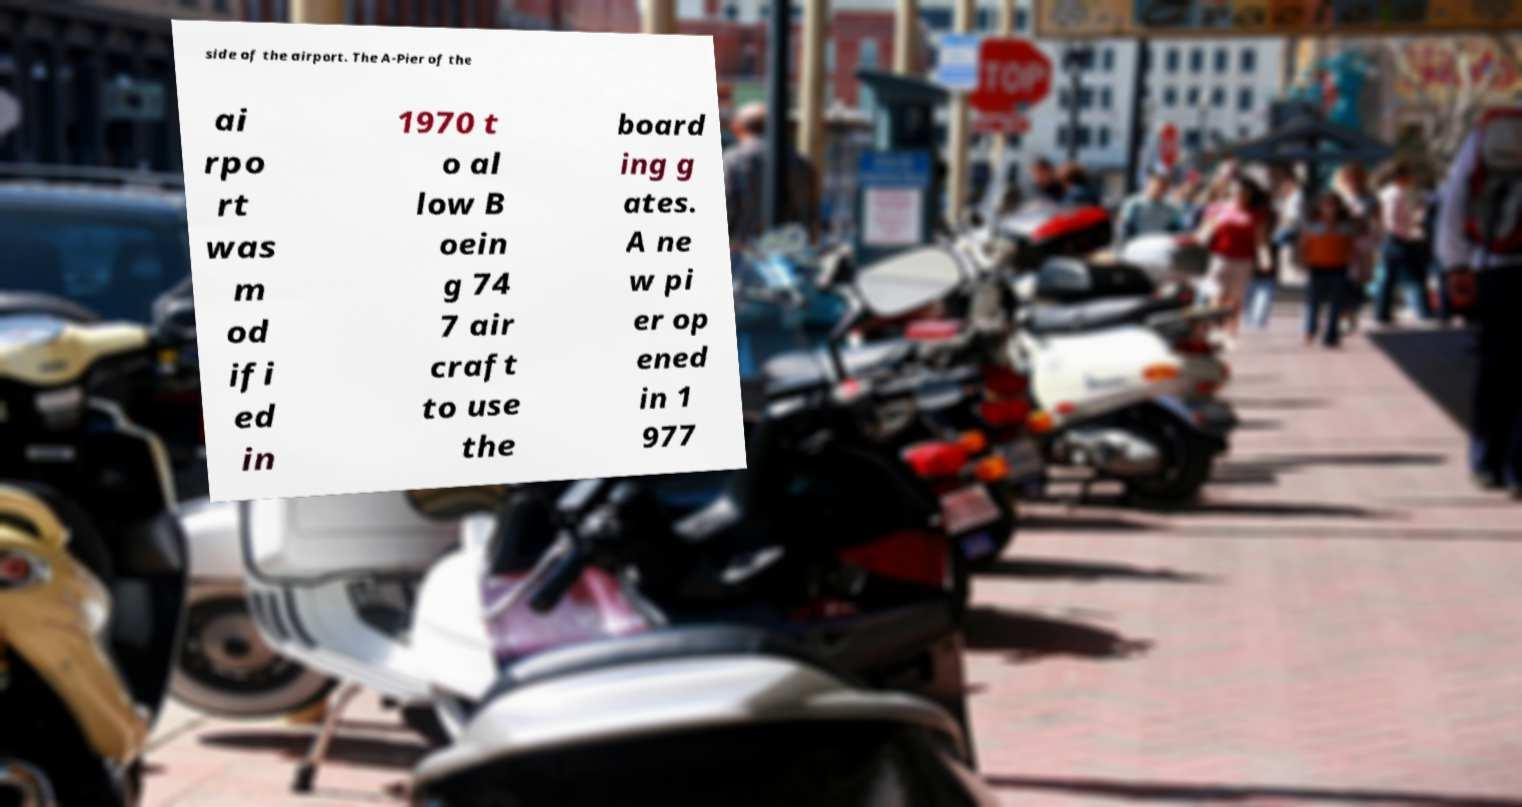What messages or text are displayed in this image? I need them in a readable, typed format. side of the airport. The A-Pier of the ai rpo rt was m od ifi ed in 1970 t o al low B oein g 74 7 air craft to use the board ing g ates. A ne w pi er op ened in 1 977 